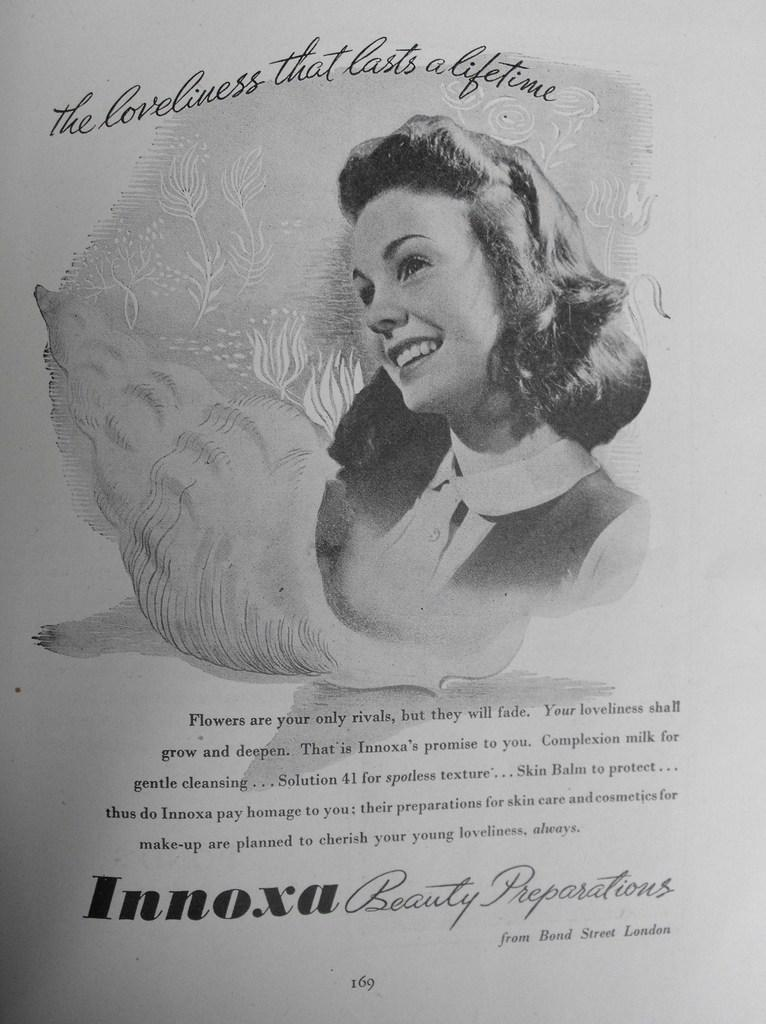What is the main subject of the image? There is a person in the image. What else can be seen in the image besides the person? There is text and a number in the image. What is the color of the background in the image? The background of the image is white in color. Can you hear the person in the image laughing? There is no sound in the image, so it is not possible to hear the person laughing. 